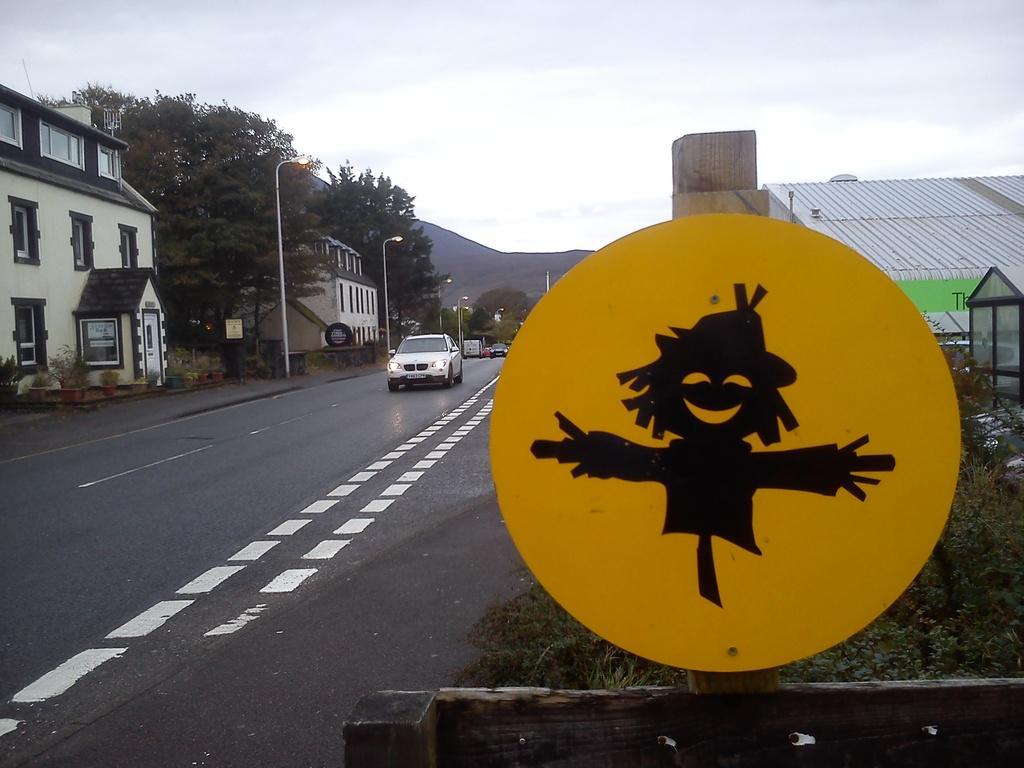Please provide a concise description of this image. In this image we can see some buildings, poles, vehicles, board, trees, road and other objects. In the background of the image there are mountains. At the top of the image there is the sky. At the bottom of the image there is the road. On the right side of the image there are wooden objects, board and other objects. 